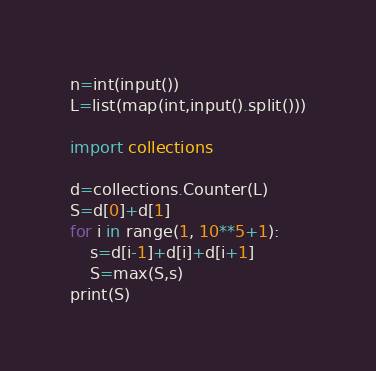<code> <loc_0><loc_0><loc_500><loc_500><_Python_>n=int(input())
L=list(map(int,input().split()))

import collections

d=collections.Counter(L)
S=d[0]+d[1]
for i in range(1, 10**5+1):
	s=d[i-1]+d[i]+d[i+1]
	S=max(S,s)
print(S)</code> 